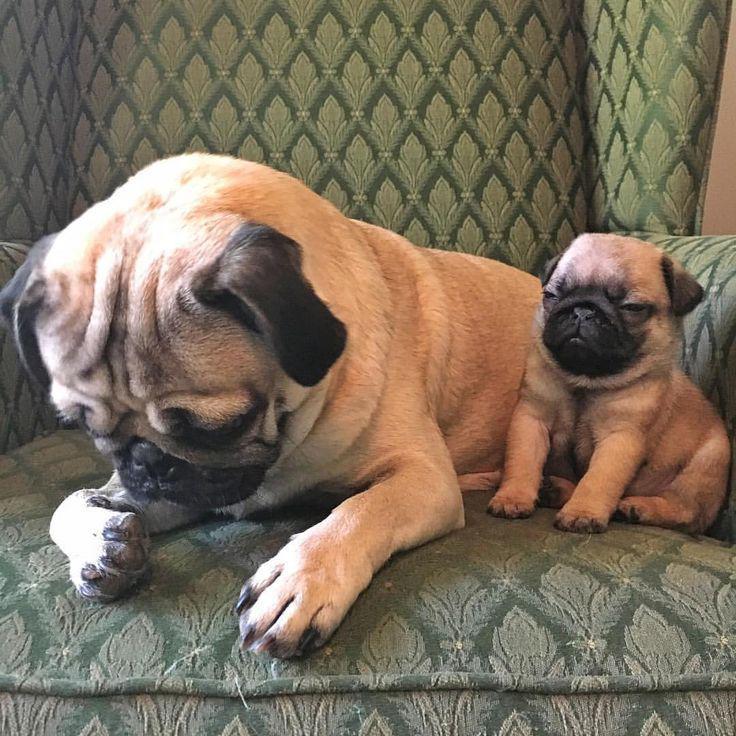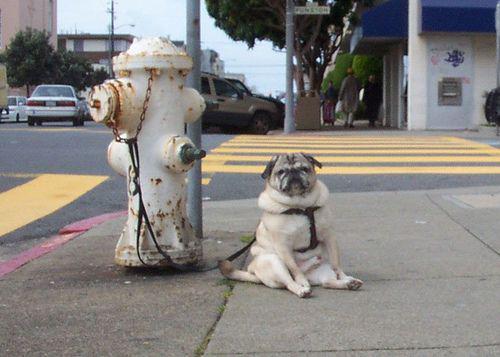The first image is the image on the left, the second image is the image on the right. Examine the images to the left and right. Is the description "One image shows a pug sitting, with its hind legs extended, on cement next to something made of metal." accurate? Answer yes or no. Yes. The first image is the image on the left, the second image is the image on the right. For the images displayed, is the sentence "The left image contains no more than one dog." factually correct? Answer yes or no. No. 